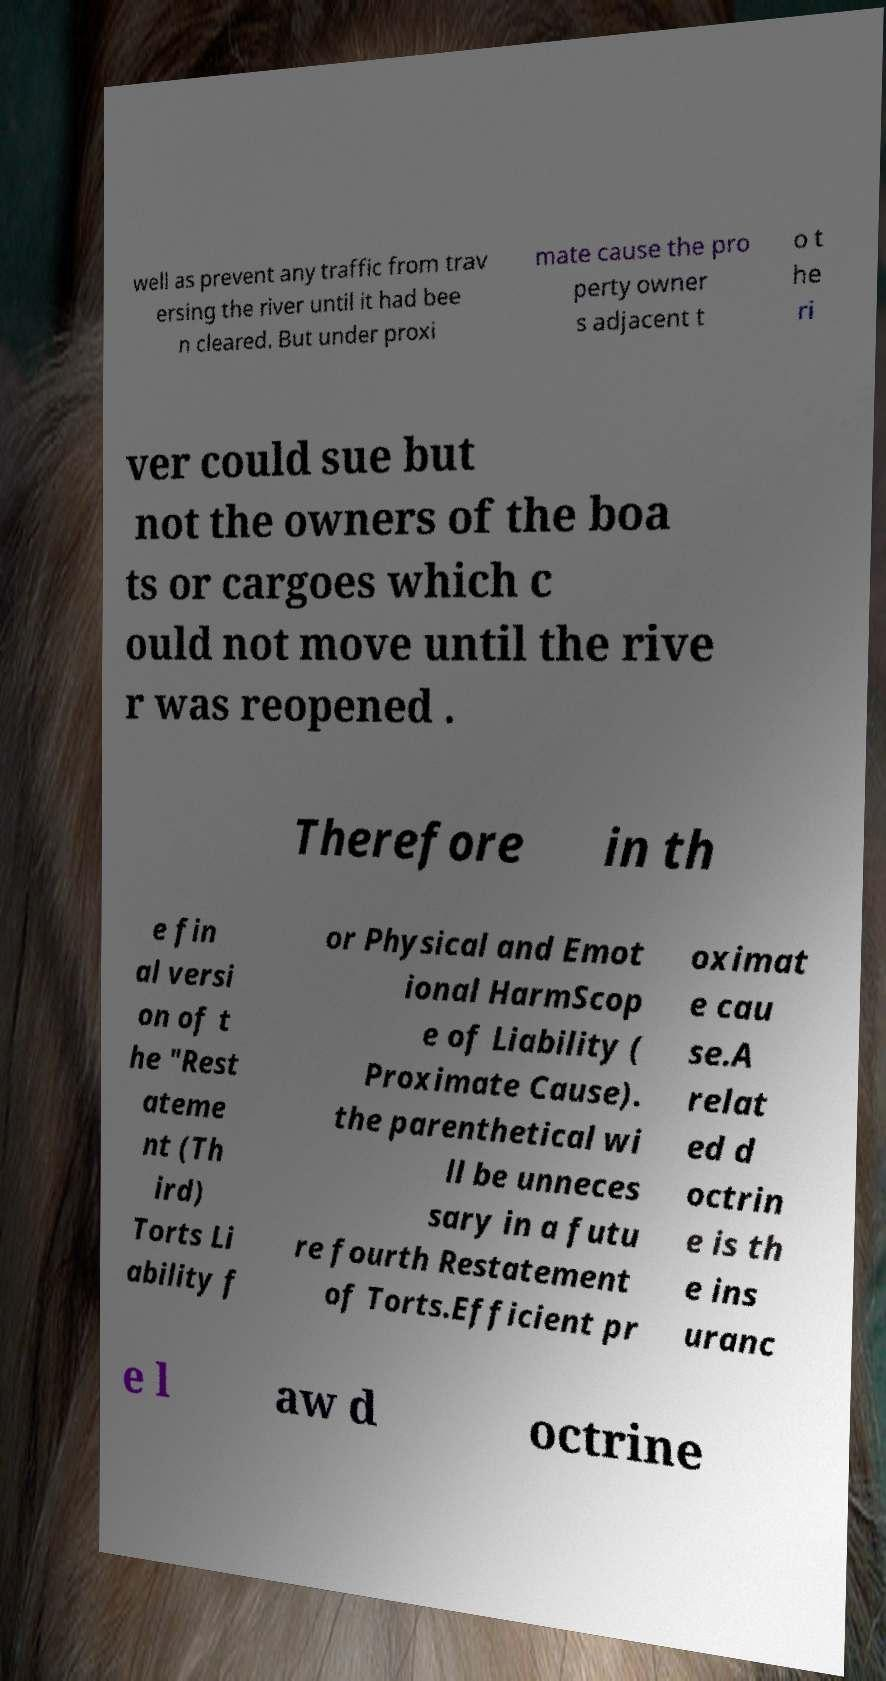Can you accurately transcribe the text from the provided image for me? well as prevent any traffic from trav ersing the river until it had bee n cleared. But under proxi mate cause the pro perty owner s adjacent t o t he ri ver could sue but not the owners of the boa ts or cargoes which c ould not move until the rive r was reopened . Therefore in th e fin al versi on of t he "Rest ateme nt (Th ird) Torts Li ability f or Physical and Emot ional HarmScop e of Liability ( Proximate Cause). the parenthetical wi ll be unneces sary in a futu re fourth Restatement of Torts.Efficient pr oximat e cau se.A relat ed d octrin e is th e ins uranc e l aw d octrine 